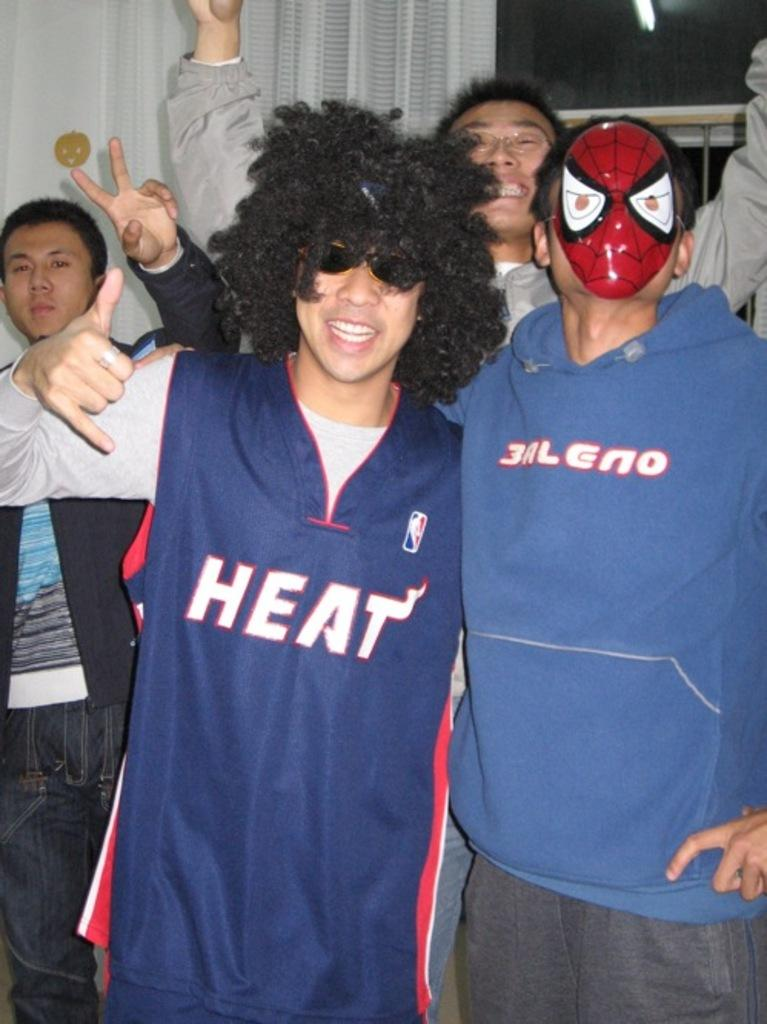<image>
Create a compact narrative representing the image presented. A group of guys at a party with the boy in the Heat jersey wearing a wig and the boy in the 3aleno sweatshirt wearing a spiderman mask. 